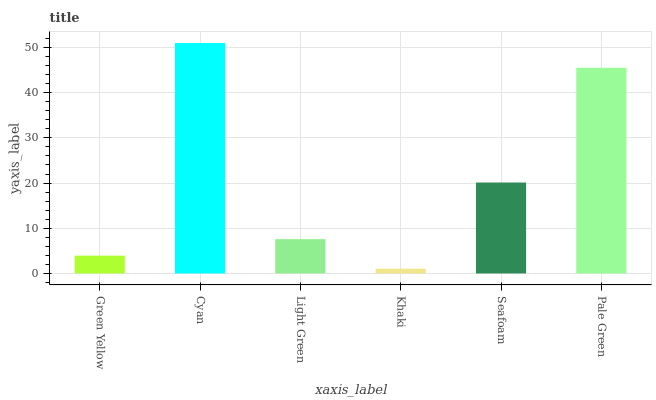Is Khaki the minimum?
Answer yes or no. Yes. Is Cyan the maximum?
Answer yes or no. Yes. Is Light Green the minimum?
Answer yes or no. No. Is Light Green the maximum?
Answer yes or no. No. Is Cyan greater than Light Green?
Answer yes or no. Yes. Is Light Green less than Cyan?
Answer yes or no. Yes. Is Light Green greater than Cyan?
Answer yes or no. No. Is Cyan less than Light Green?
Answer yes or no. No. Is Seafoam the high median?
Answer yes or no. Yes. Is Light Green the low median?
Answer yes or no. Yes. Is Pale Green the high median?
Answer yes or no. No. Is Green Yellow the low median?
Answer yes or no. No. 